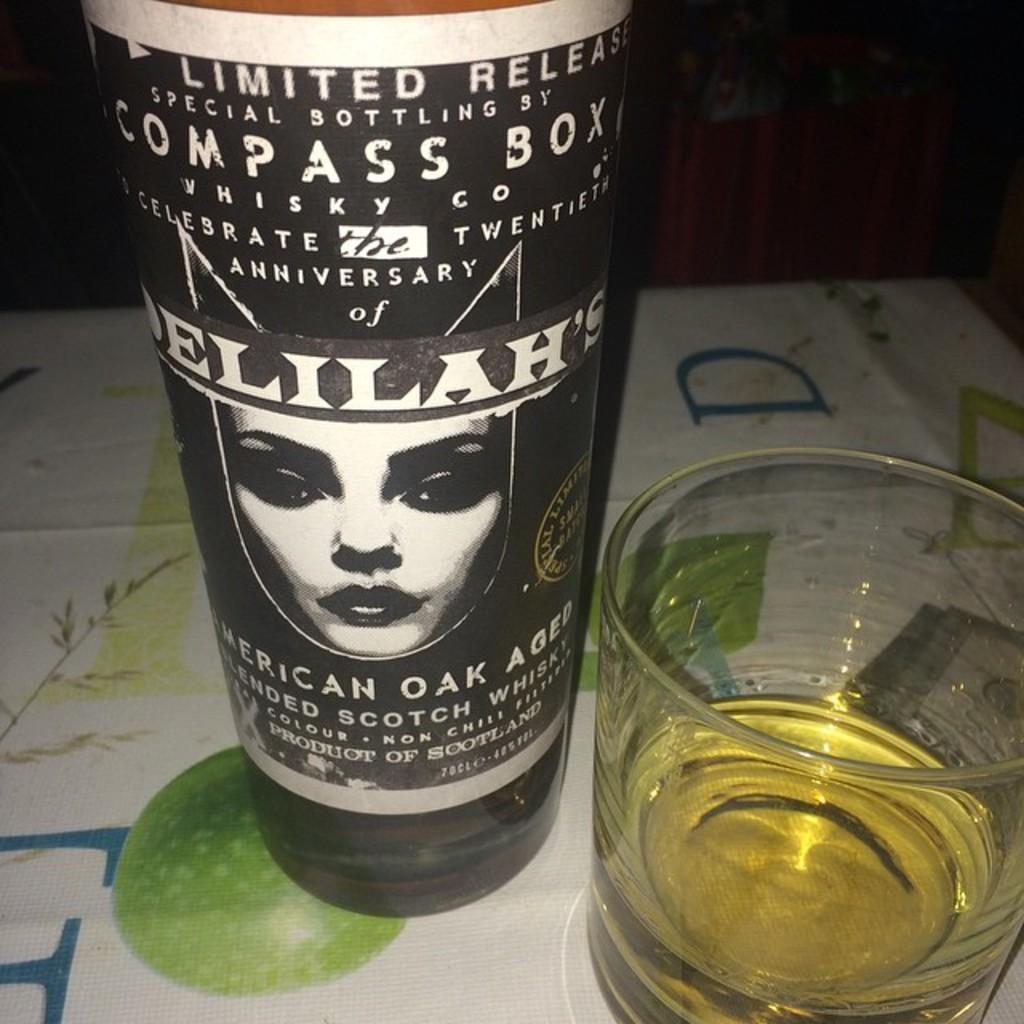What is on the table in the image? There is a glass with a drink on the table. Can you describe the bottle in the image? There is a bottle with a label on it. What type of alarm can be heard going off in the image? There is no alarm present in the image, so it is not possible to determine if any alarm is going off. 